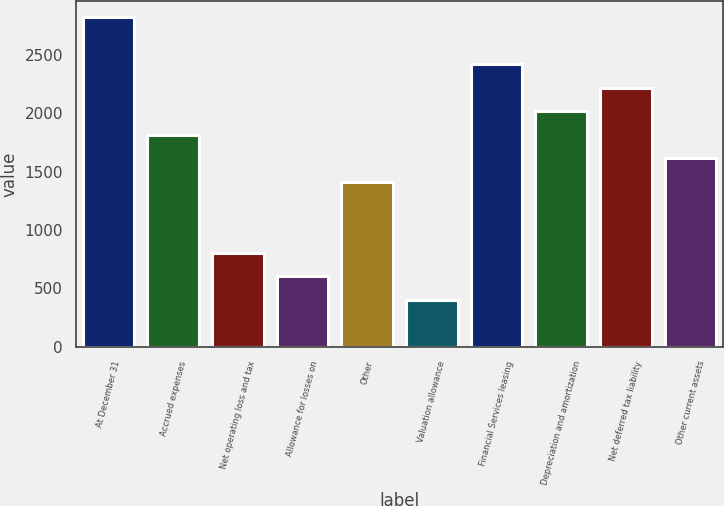Convert chart. <chart><loc_0><loc_0><loc_500><loc_500><bar_chart><fcel>At December 31<fcel>Accrued expenses<fcel>Net operating loss and tax<fcel>Allowance for losses on<fcel>Other<fcel>Valuation allowance<fcel>Financial Services leasing<fcel>Depreciation and amortization<fcel>Net deferred tax liability<fcel>Other current assets<nl><fcel>2819.24<fcel>1812.69<fcel>806.14<fcel>604.83<fcel>1410.07<fcel>403.52<fcel>2416.62<fcel>2014<fcel>2215.31<fcel>1611.38<nl></chart> 